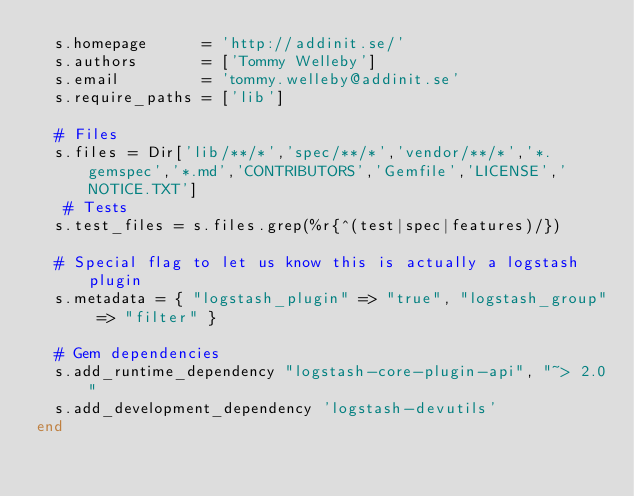<code> <loc_0><loc_0><loc_500><loc_500><_Ruby_>  s.homepage      = 'http://addinit.se/'
  s.authors       = ['Tommy Welleby']
  s.email         = 'tommy.welleby@addinit.se'
  s.require_paths = ['lib']

  # Files
  s.files = Dir['lib/**/*','spec/**/*','vendor/**/*','*.gemspec','*.md','CONTRIBUTORS','Gemfile','LICENSE','NOTICE.TXT']
   # Tests
  s.test_files = s.files.grep(%r{^(test|spec|features)/})

  # Special flag to let us know this is actually a logstash plugin
  s.metadata = { "logstash_plugin" => "true", "logstash_group" => "filter" }

  # Gem dependencies
  s.add_runtime_dependency "logstash-core-plugin-api", "~> 2.0"
  s.add_development_dependency 'logstash-devutils'
end
</code> 